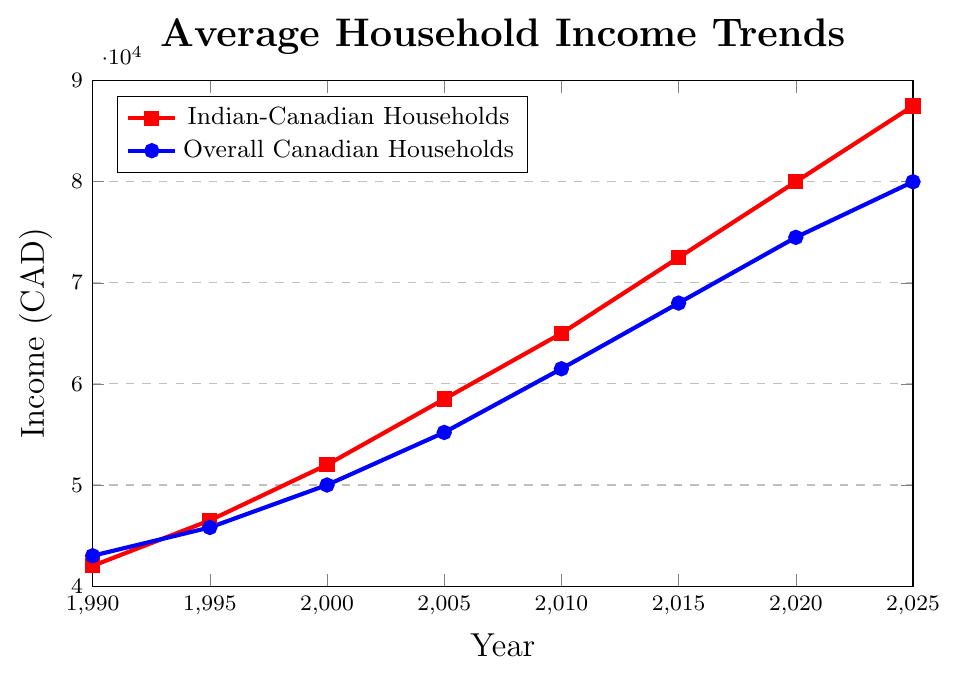What's the income difference between Indian-Canadian households and overall Canadian households in 1990? In 1990, the income for Indian-Canadian households is 42000 CAD, and for overall Canadian households, it is 43000 CAD. The difference is 43000 - 42000.
Answer: 1000 CAD Which year shows the smallest income gap between Indian-Canadian households and overall Canadian households? From the data: The gaps are 1000 in 1990, 700 in 1995, 2000 in 2000, 3300 in 2005, 3500 in 2010, 4500 in 2015, 5500 in 2020, and 7500 in 2025. The smallest gap is in 1995.
Answer: 1995 By how much did the income for Indian-Canadian households increase from 1990 to 2010? In 1990, the income is 42000 CAD, and in 2010, it is 65000 CAD. The increase is 65000 - 42000.
Answer: 23000 CAD How does the trend of income growth compare between Indian-Canadian households and overall Canadian households from 2000 to 2020? From 2000 to 2020, for Indian-Canadian households, the income increased from 52000 to 80000, an increase of 28000. For overall Canadian households, the increase is from 50000 to 74500, which is 24500. Indian-Canadian households see a higher increase.
Answer: Indian-Canadian households have a higher increase What is the average income of Indian-Canadian households over the years provided? Sum the incomes for Indian-Canadian households for all years and divide by the number of years: (42000 + 46500 + 52000 + 58500 + 65000 + 72500 + 80000 + 87500) / 8.
Answer: 62812.5 CAD In which year does the income for Indian-Canadian households first exceed 70000 CAD? The income for Indian-Canadian households first exceeds 70000 CAD in 2015, where it is 72500 CAD.
Answer: 2015 Between 1990 and 2005, how much did the overall Canadian household income grow in comparison to the Indian-Canadian household income? For overall Canadian households, from 1990 to 2005, income grew from 43000 to 55200 (an increase of 12200). For Indian-Canadian households, from 1990 to 2005, it grew from 42000 to 58500 (an increase of 16500).
Answer: Indian-Canadian households saw a higher increase (16500 CAD vs. 12200 CAD) Which year shows a higher income for Indian-Canadian households compared to overall Canadian households? Compare incomes for all years: Indian-Canadian households have higher incomes in 2020 (80000 vs 74500) and 2025 (87500 vs 80000).
Answer: 2020 and 2025 